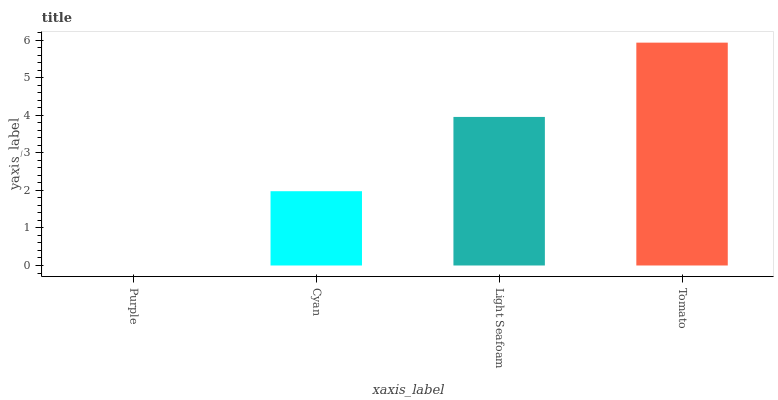Is Purple the minimum?
Answer yes or no. Yes. Is Tomato the maximum?
Answer yes or no. Yes. Is Cyan the minimum?
Answer yes or no. No. Is Cyan the maximum?
Answer yes or no. No. Is Cyan greater than Purple?
Answer yes or no. Yes. Is Purple less than Cyan?
Answer yes or no. Yes. Is Purple greater than Cyan?
Answer yes or no. No. Is Cyan less than Purple?
Answer yes or no. No. Is Light Seafoam the high median?
Answer yes or no. Yes. Is Cyan the low median?
Answer yes or no. Yes. Is Cyan the high median?
Answer yes or no. No. Is Light Seafoam the low median?
Answer yes or no. No. 